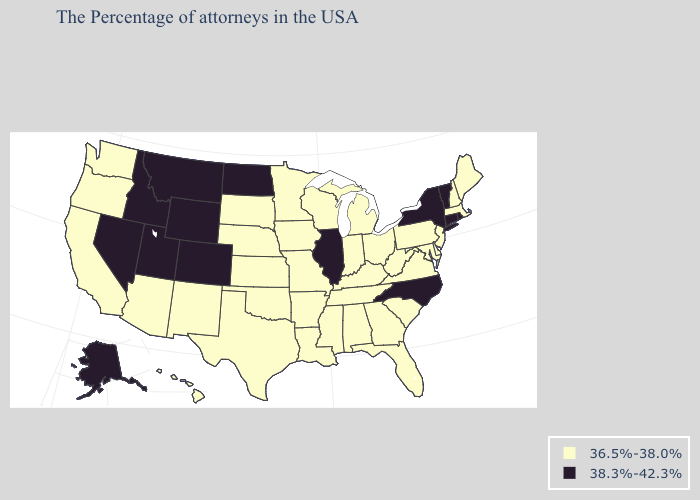Does Missouri have the lowest value in the MidWest?
Give a very brief answer. Yes. Does North Carolina have the highest value in the USA?
Keep it brief. Yes. What is the lowest value in the USA?
Answer briefly. 36.5%-38.0%. Among the states that border Mississippi , which have the lowest value?
Write a very short answer. Alabama, Tennessee, Louisiana, Arkansas. Does Indiana have the lowest value in the MidWest?
Answer briefly. Yes. Name the states that have a value in the range 36.5%-38.0%?
Give a very brief answer. Maine, Massachusetts, New Hampshire, New Jersey, Delaware, Maryland, Pennsylvania, Virginia, South Carolina, West Virginia, Ohio, Florida, Georgia, Michigan, Kentucky, Indiana, Alabama, Tennessee, Wisconsin, Mississippi, Louisiana, Missouri, Arkansas, Minnesota, Iowa, Kansas, Nebraska, Oklahoma, Texas, South Dakota, New Mexico, Arizona, California, Washington, Oregon, Hawaii. Which states have the lowest value in the MidWest?
Short answer required. Ohio, Michigan, Indiana, Wisconsin, Missouri, Minnesota, Iowa, Kansas, Nebraska, South Dakota. Among the states that border Vermont , does New York have the lowest value?
Give a very brief answer. No. Among the states that border Delaware , which have the lowest value?
Answer briefly. New Jersey, Maryland, Pennsylvania. Among the states that border Washington , does Idaho have the highest value?
Write a very short answer. Yes. What is the lowest value in the MidWest?
Concise answer only. 36.5%-38.0%. Does Illinois have the highest value in the MidWest?
Concise answer only. Yes. Among the states that border New Jersey , which have the highest value?
Quick response, please. New York. What is the highest value in the West ?
Answer briefly. 38.3%-42.3%. Name the states that have a value in the range 36.5%-38.0%?
Be succinct. Maine, Massachusetts, New Hampshire, New Jersey, Delaware, Maryland, Pennsylvania, Virginia, South Carolina, West Virginia, Ohio, Florida, Georgia, Michigan, Kentucky, Indiana, Alabama, Tennessee, Wisconsin, Mississippi, Louisiana, Missouri, Arkansas, Minnesota, Iowa, Kansas, Nebraska, Oklahoma, Texas, South Dakota, New Mexico, Arizona, California, Washington, Oregon, Hawaii. 